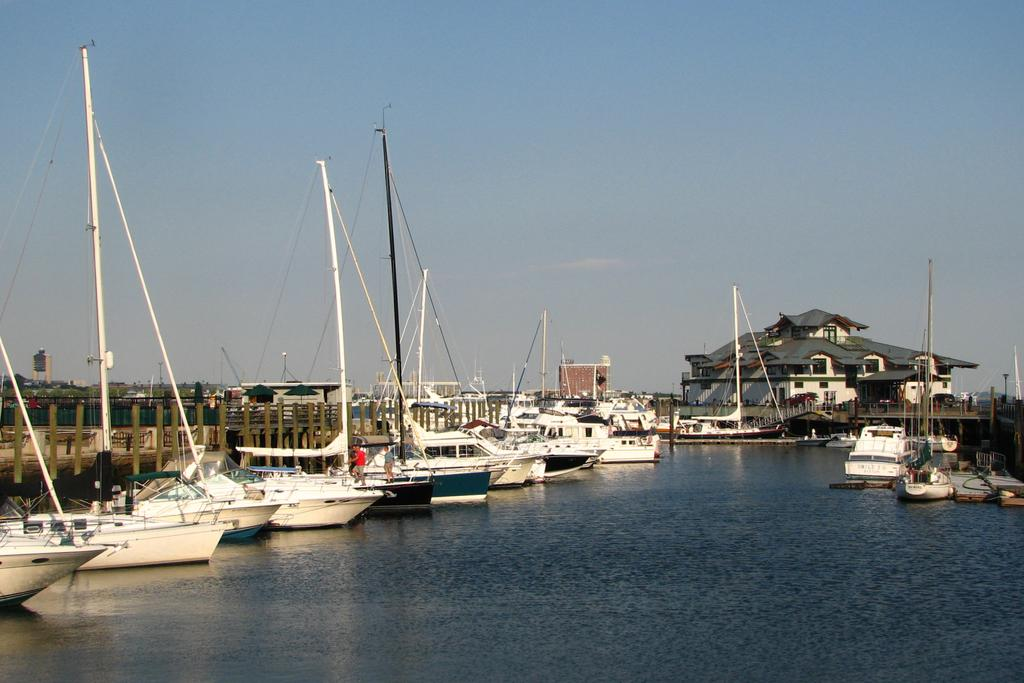What type of vehicles can be seen in the image? There are ships on the water in the image. What type of barrier is present in the image? There is fencing visible in the image. What can be seen in the distance in the image? There are buildings in the background of the image. What type of jewel is being used to control the speed of the ships in the image? There is no jewel present in the image, and ships do not use jewels to control their speed. 